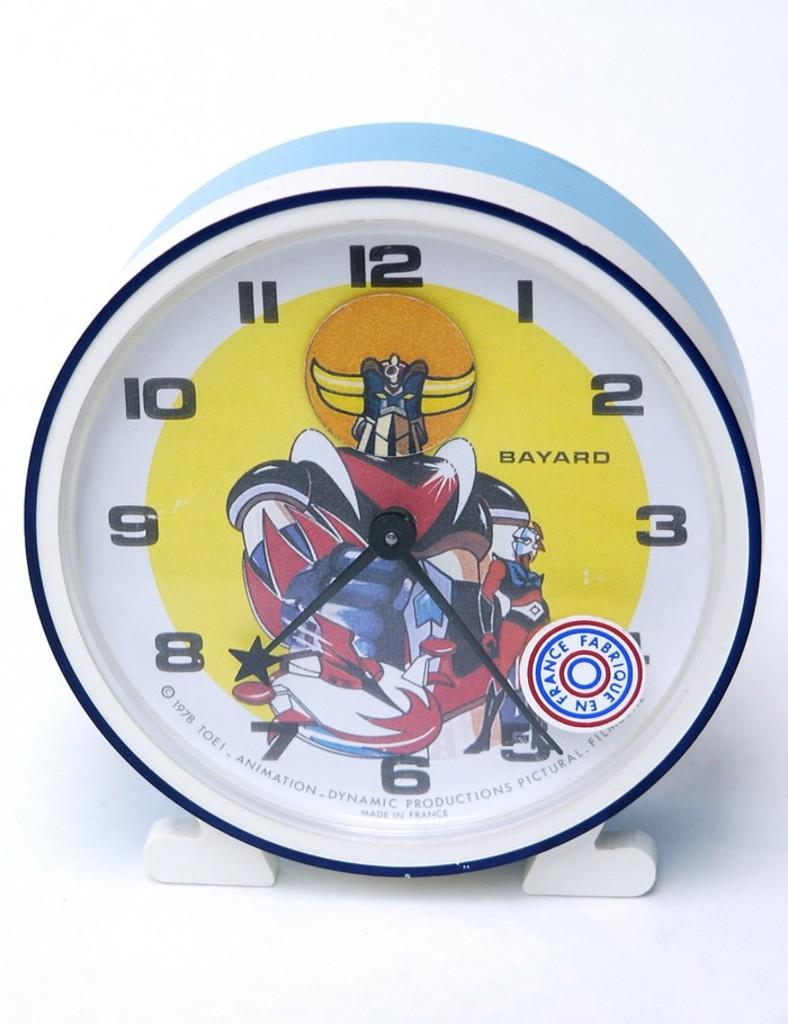<image>
Offer a succinct explanation of the picture presented. Face of a watch which says BAYARD on the front. 